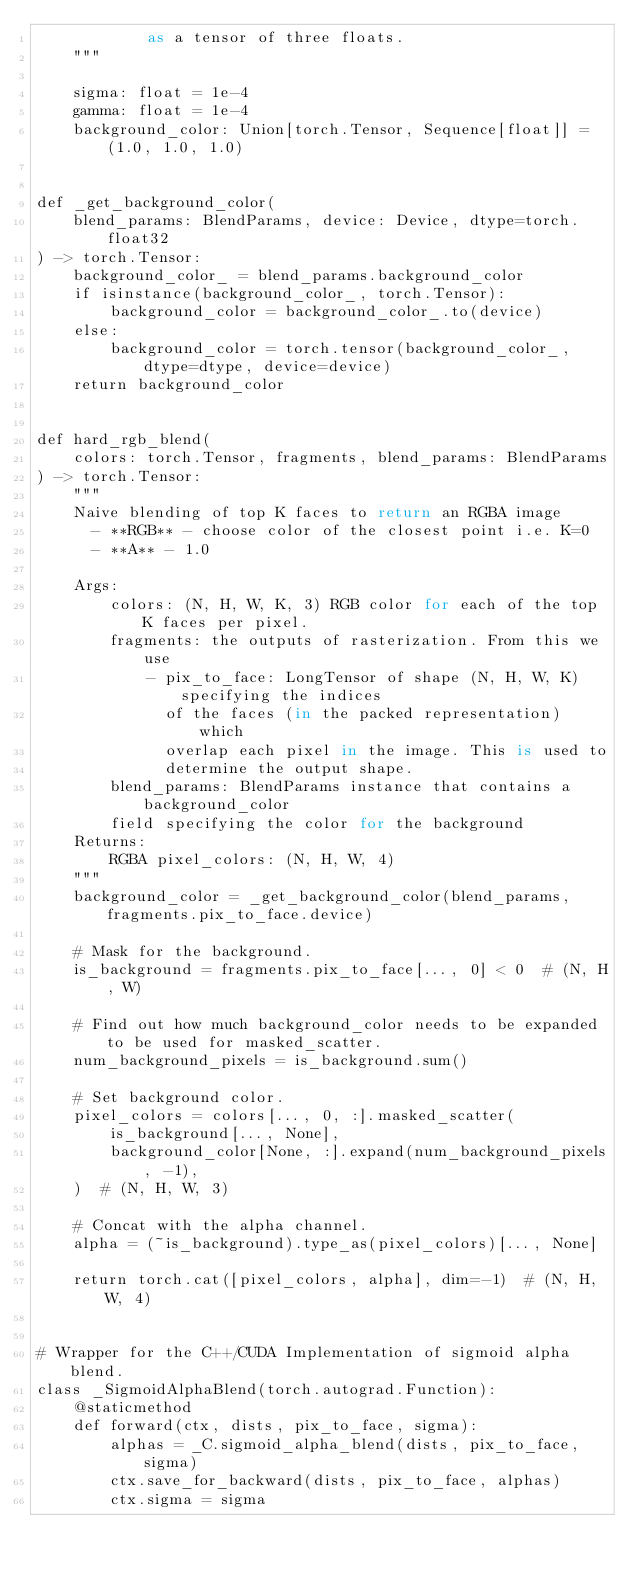<code> <loc_0><loc_0><loc_500><loc_500><_Python_>            as a tensor of three floats.
    """

    sigma: float = 1e-4
    gamma: float = 1e-4
    background_color: Union[torch.Tensor, Sequence[float]] = (1.0, 1.0, 1.0)


def _get_background_color(
    blend_params: BlendParams, device: Device, dtype=torch.float32
) -> torch.Tensor:
    background_color_ = blend_params.background_color
    if isinstance(background_color_, torch.Tensor):
        background_color = background_color_.to(device)
    else:
        background_color = torch.tensor(background_color_, dtype=dtype, device=device)
    return background_color


def hard_rgb_blend(
    colors: torch.Tensor, fragments, blend_params: BlendParams
) -> torch.Tensor:
    """
    Naive blending of top K faces to return an RGBA image
      - **RGB** - choose color of the closest point i.e. K=0
      - **A** - 1.0

    Args:
        colors: (N, H, W, K, 3) RGB color for each of the top K faces per pixel.
        fragments: the outputs of rasterization. From this we use
            - pix_to_face: LongTensor of shape (N, H, W, K) specifying the indices
              of the faces (in the packed representation) which
              overlap each pixel in the image. This is used to
              determine the output shape.
        blend_params: BlendParams instance that contains a background_color
        field specifying the color for the background
    Returns:
        RGBA pixel_colors: (N, H, W, 4)
    """
    background_color = _get_background_color(blend_params, fragments.pix_to_face.device)

    # Mask for the background.
    is_background = fragments.pix_to_face[..., 0] < 0  # (N, H, W)

    # Find out how much background_color needs to be expanded to be used for masked_scatter.
    num_background_pixels = is_background.sum()

    # Set background color.
    pixel_colors = colors[..., 0, :].masked_scatter(
        is_background[..., None],
        background_color[None, :].expand(num_background_pixels, -1),
    )  # (N, H, W, 3)

    # Concat with the alpha channel.
    alpha = (~is_background).type_as(pixel_colors)[..., None]

    return torch.cat([pixel_colors, alpha], dim=-1)  # (N, H, W, 4)


# Wrapper for the C++/CUDA Implementation of sigmoid alpha blend.
class _SigmoidAlphaBlend(torch.autograd.Function):
    @staticmethod
    def forward(ctx, dists, pix_to_face, sigma):
        alphas = _C.sigmoid_alpha_blend(dists, pix_to_face, sigma)
        ctx.save_for_backward(dists, pix_to_face, alphas)
        ctx.sigma = sigma</code> 